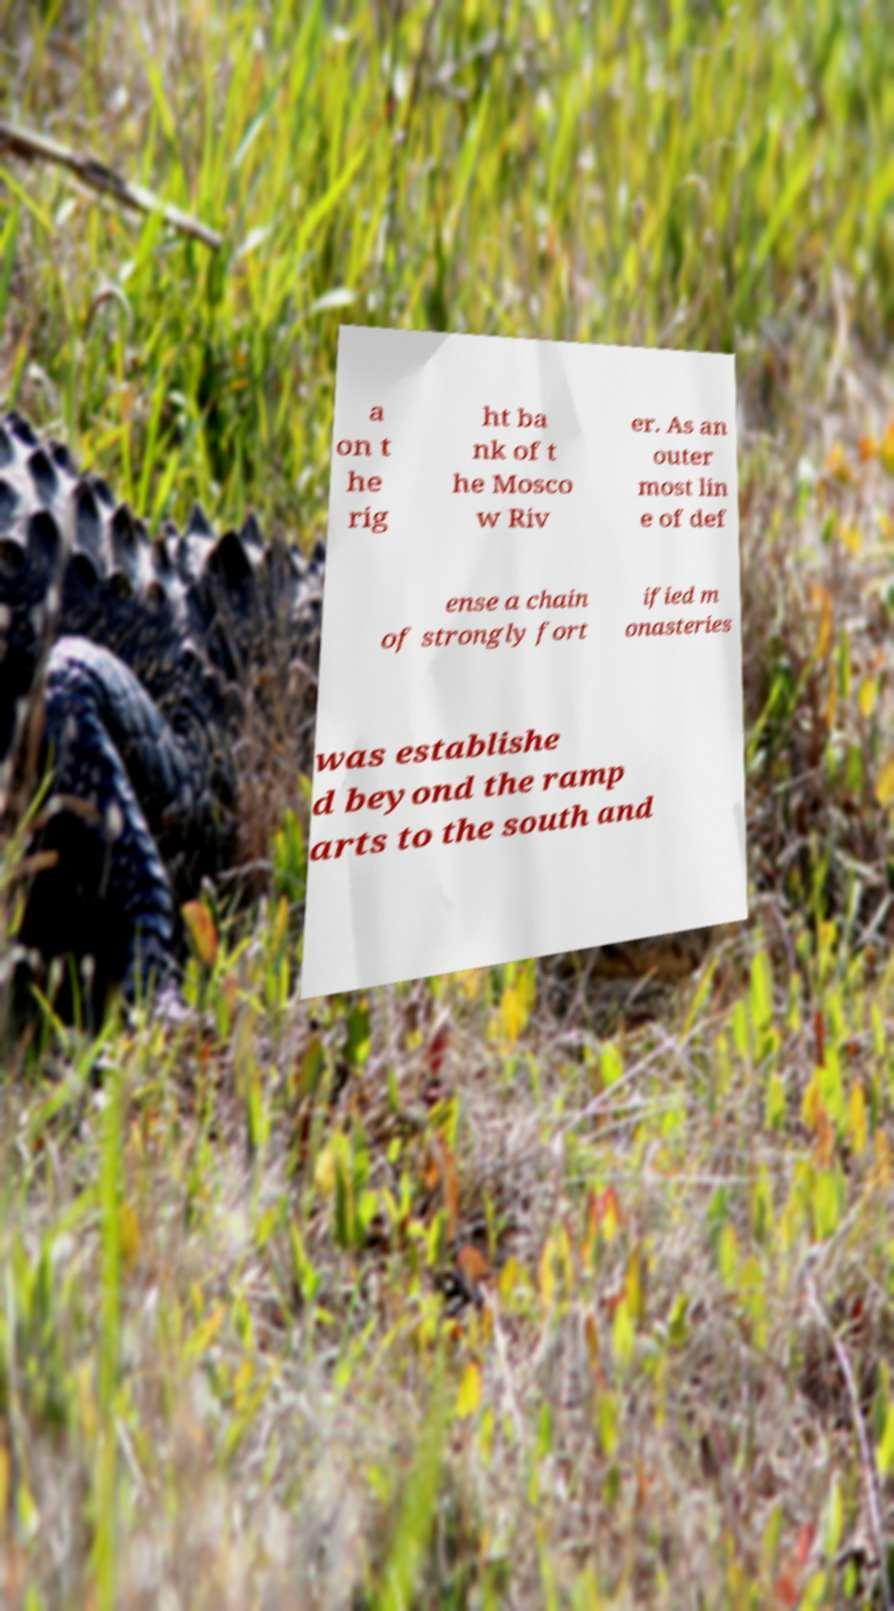Can you read and provide the text displayed in the image?This photo seems to have some interesting text. Can you extract and type it out for me? a on t he rig ht ba nk of t he Mosco w Riv er. As an outer most lin e of def ense a chain of strongly fort ified m onasteries was establishe d beyond the ramp arts to the south and 